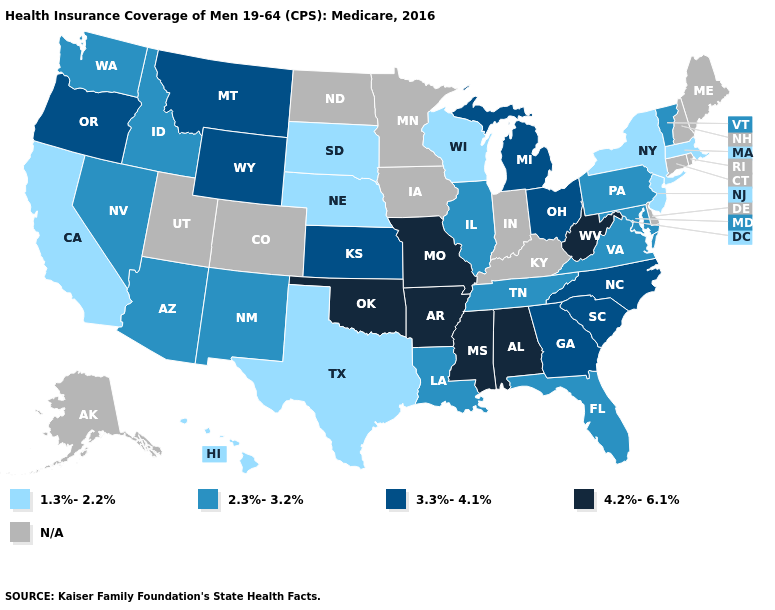Is the legend a continuous bar?
Quick response, please. No. What is the value of Delaware?
Be succinct. N/A. What is the value of Virginia?
Short answer required. 2.3%-3.2%. What is the lowest value in the MidWest?
Give a very brief answer. 1.3%-2.2%. What is the lowest value in the USA?
Concise answer only. 1.3%-2.2%. What is the value of Georgia?
Answer briefly. 3.3%-4.1%. Which states hav the highest value in the South?
Concise answer only. Alabama, Arkansas, Mississippi, Oklahoma, West Virginia. Name the states that have a value in the range 3.3%-4.1%?
Short answer required. Georgia, Kansas, Michigan, Montana, North Carolina, Ohio, Oregon, South Carolina, Wyoming. Which states hav the highest value in the MidWest?
Be succinct. Missouri. Does Nebraska have the lowest value in the MidWest?
Concise answer only. Yes. Among the states that border Oklahoma , does Arkansas have the highest value?
Short answer required. Yes. What is the value of Maryland?
Quick response, please. 2.3%-3.2%. What is the highest value in states that border Idaho?
Answer briefly. 3.3%-4.1%. Among the states that border California , which have the highest value?
Short answer required. Oregon. 